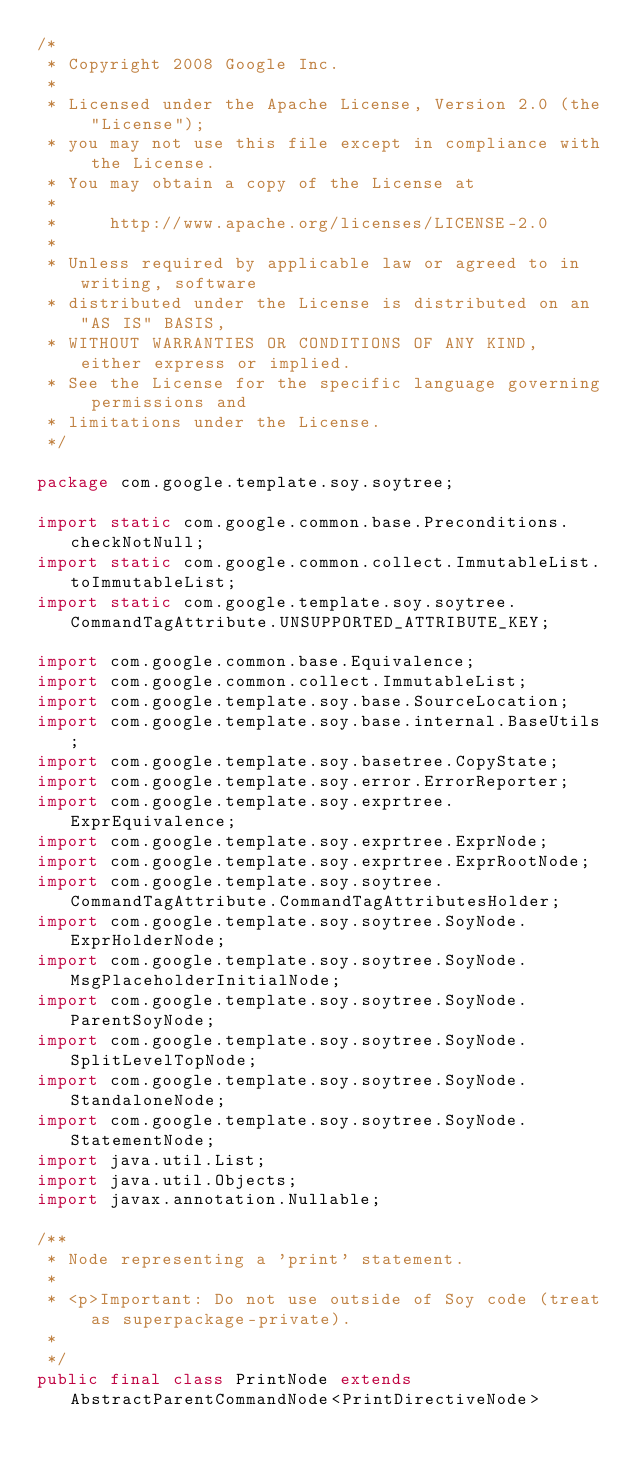<code> <loc_0><loc_0><loc_500><loc_500><_Java_>/*
 * Copyright 2008 Google Inc.
 *
 * Licensed under the Apache License, Version 2.0 (the "License");
 * you may not use this file except in compliance with the License.
 * You may obtain a copy of the License at
 *
 *     http://www.apache.org/licenses/LICENSE-2.0
 *
 * Unless required by applicable law or agreed to in writing, software
 * distributed under the License is distributed on an "AS IS" BASIS,
 * WITHOUT WARRANTIES OR CONDITIONS OF ANY KIND, either express or implied.
 * See the License for the specific language governing permissions and
 * limitations under the License.
 */

package com.google.template.soy.soytree;

import static com.google.common.base.Preconditions.checkNotNull;
import static com.google.common.collect.ImmutableList.toImmutableList;
import static com.google.template.soy.soytree.CommandTagAttribute.UNSUPPORTED_ATTRIBUTE_KEY;

import com.google.common.base.Equivalence;
import com.google.common.collect.ImmutableList;
import com.google.template.soy.base.SourceLocation;
import com.google.template.soy.base.internal.BaseUtils;
import com.google.template.soy.basetree.CopyState;
import com.google.template.soy.error.ErrorReporter;
import com.google.template.soy.exprtree.ExprEquivalence;
import com.google.template.soy.exprtree.ExprNode;
import com.google.template.soy.exprtree.ExprRootNode;
import com.google.template.soy.soytree.CommandTagAttribute.CommandTagAttributesHolder;
import com.google.template.soy.soytree.SoyNode.ExprHolderNode;
import com.google.template.soy.soytree.SoyNode.MsgPlaceholderInitialNode;
import com.google.template.soy.soytree.SoyNode.ParentSoyNode;
import com.google.template.soy.soytree.SoyNode.SplitLevelTopNode;
import com.google.template.soy.soytree.SoyNode.StandaloneNode;
import com.google.template.soy.soytree.SoyNode.StatementNode;
import java.util.List;
import java.util.Objects;
import javax.annotation.Nullable;

/**
 * Node representing a 'print' statement.
 *
 * <p>Important: Do not use outside of Soy code (treat as superpackage-private).
 *
 */
public final class PrintNode extends AbstractParentCommandNode<PrintDirectiveNode></code> 